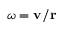Convert formula to latex. <formula><loc_0><loc_0><loc_500><loc_500>\omega = v / r</formula> 